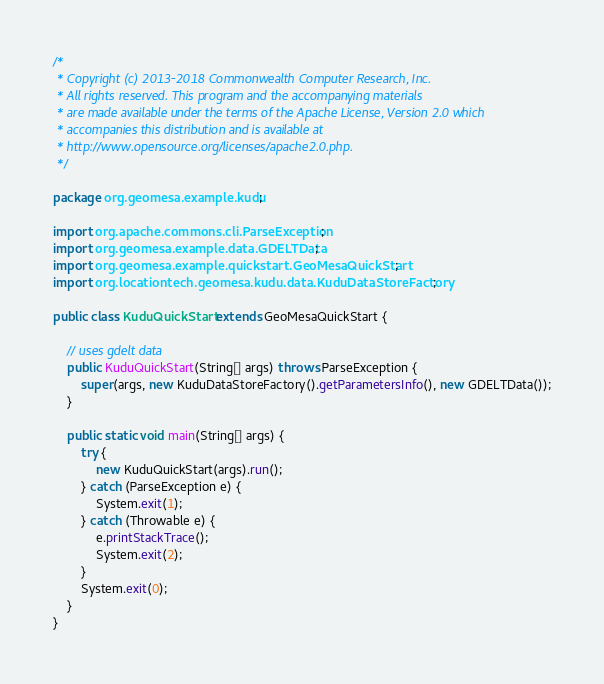<code> <loc_0><loc_0><loc_500><loc_500><_Java_>/*
 * Copyright (c) 2013-2018 Commonwealth Computer Research, Inc.
 * All rights reserved. This program and the accompanying materials
 * are made available under the terms of the Apache License, Version 2.0 which
 * accompanies this distribution and is available at
 * http://www.opensource.org/licenses/apache2.0.php.
 */

package org.geomesa.example.kudu;

import org.apache.commons.cli.ParseException;
import org.geomesa.example.data.GDELTData;
import org.geomesa.example.quickstart.GeoMesaQuickStart;
import org.locationtech.geomesa.kudu.data.KuduDataStoreFactory;

public class KuduQuickStart extends GeoMesaQuickStart {

    // uses gdelt data
    public KuduQuickStart(String[] args) throws ParseException {
        super(args, new KuduDataStoreFactory().getParametersInfo(), new GDELTData());
    }

    public static void main(String[] args) {
        try {
            new KuduQuickStart(args).run();
        } catch (ParseException e) {
            System.exit(1);
        } catch (Throwable e) {
            e.printStackTrace();
            System.exit(2);
        }
        System.exit(0);
    }
}
</code> 